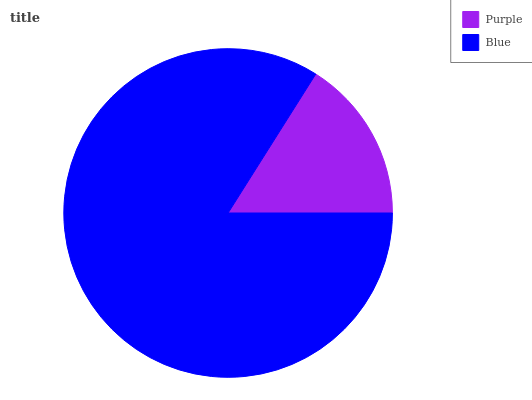Is Purple the minimum?
Answer yes or no. Yes. Is Blue the maximum?
Answer yes or no. Yes. Is Blue the minimum?
Answer yes or no. No. Is Blue greater than Purple?
Answer yes or no. Yes. Is Purple less than Blue?
Answer yes or no. Yes. Is Purple greater than Blue?
Answer yes or no. No. Is Blue less than Purple?
Answer yes or no. No. Is Blue the high median?
Answer yes or no. Yes. Is Purple the low median?
Answer yes or no. Yes. Is Purple the high median?
Answer yes or no. No. Is Blue the low median?
Answer yes or no. No. 